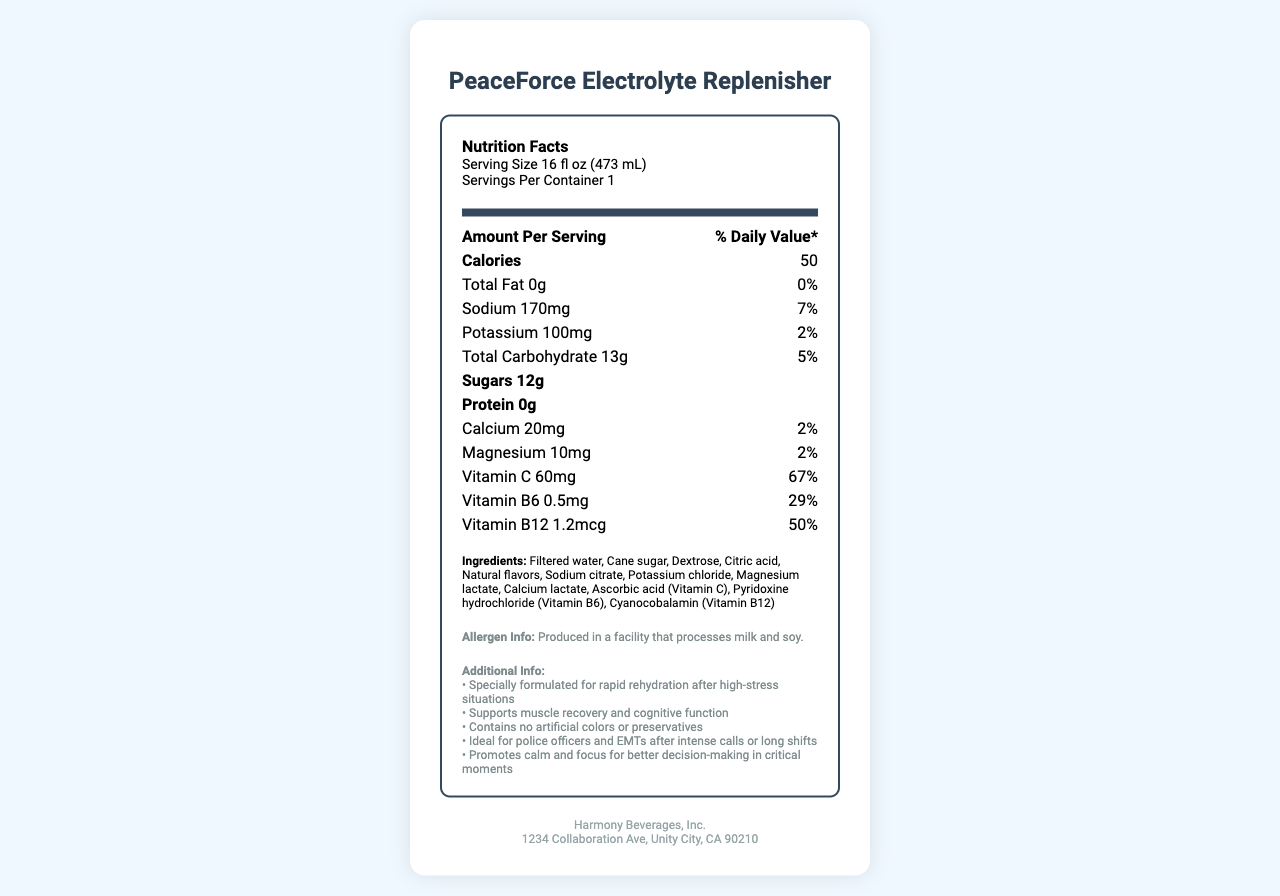What is the serving size of PeaceForce Electrolyte Replenisher? The serving size is listed in the serving information section at the top of the Nutrition Facts label.
Answer: 16 fl oz (473 mL) How many calories are in one serving of the drink? The number of calories is listed directly below the "Amount Per Serving" section.
Answer: 50 What percentage of the Daily Value of Vitamin C does this drink provide? The percentage of the daily value for Vitamin C is provided next to its amount in the nutrient list.
Answer: 67% List three key ingredients in the PeaceForce Electrolyte Replenisher. The key ingredients are listed under the Ingredients section on the Nutrition Facts label.
Answer: Filtered water, Cane sugar, Dextrose What is the amount of sodium per serving in the drink? The amount of sodium per serving is listed in the nutrient section of the Nutrition Facts label.
Answer: 170mg How much protein does the PeaceForce Electrolyte Replenisher contain? The amount of protein is listed in the nutrient section of the Nutrition Facts label, indicating that there is none.
Answer: 0g Who is the manufacturer of PeaceForce Electrolyte Replenisher? The manufacturer's information is found at the bottom of the label.
Answer: Harmony Beverages, Inc. List two benefits that the drink claims to support. The benefits are mentioned under the Additional Info section on the Nutrition Facts label.
Answer: Muscle recovery, cognitive function What is the address of the manufacturer Harmony Beverages, Inc.? The address is provided at the bottom of the label with the manufacturer's information.
Answer: 1234 Collaboration Ave, Unity City, CA 90210 Contains the drink any artificial colors or preservatives? The additional info section specifically mentions that the drink contains no artificial colors or preservatives.
Answer: No Which vitamin provides the highest percentage of the Daily Value in the drink? A. Vitamin C B. Vitamin B6 C. Vitamin B12 D. Magnesium Vitamin C provides 67% of the daily value, which is the highest percentage among the listed vitamins and minerals.
Answer: A. Vitamin C How much potassium is in the drink? A. 50mg B. 100mg C. 150mg D. 200mg The amount of potassium per serving is listed in the nutrient section of the Nutrition Facts label.
Answer: B. 100mg Is the drink suitable for vegans? The label does not provide explicit information about whether the drink is suitable for vegans beyond its ingredient list and allergen info.
Answer: Cannot be determined 